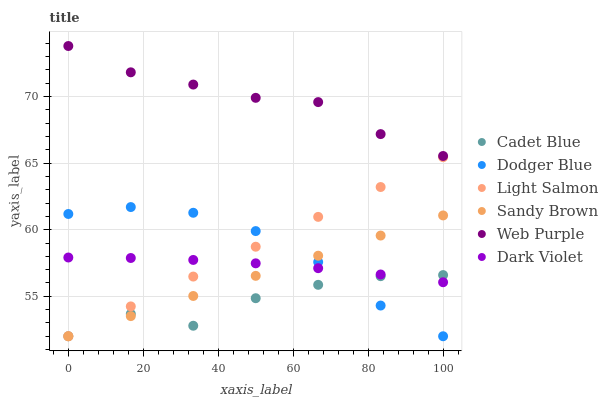Does Cadet Blue have the minimum area under the curve?
Answer yes or no. Yes. Does Web Purple have the maximum area under the curve?
Answer yes or no. Yes. Does Dark Violet have the minimum area under the curve?
Answer yes or no. No. Does Dark Violet have the maximum area under the curve?
Answer yes or no. No. Is Light Salmon the smoothest?
Answer yes or no. Yes. Is Cadet Blue the roughest?
Answer yes or no. Yes. Is Dark Violet the smoothest?
Answer yes or no. No. Is Dark Violet the roughest?
Answer yes or no. No. Does Light Salmon have the lowest value?
Answer yes or no. Yes. Does Dark Violet have the lowest value?
Answer yes or no. No. Does Web Purple have the highest value?
Answer yes or no. Yes. Does Dark Violet have the highest value?
Answer yes or no. No. Is Cadet Blue less than Web Purple?
Answer yes or no. Yes. Is Web Purple greater than Dark Violet?
Answer yes or no. Yes. Does Cadet Blue intersect Dodger Blue?
Answer yes or no. Yes. Is Cadet Blue less than Dodger Blue?
Answer yes or no. No. Is Cadet Blue greater than Dodger Blue?
Answer yes or no. No. Does Cadet Blue intersect Web Purple?
Answer yes or no. No. 